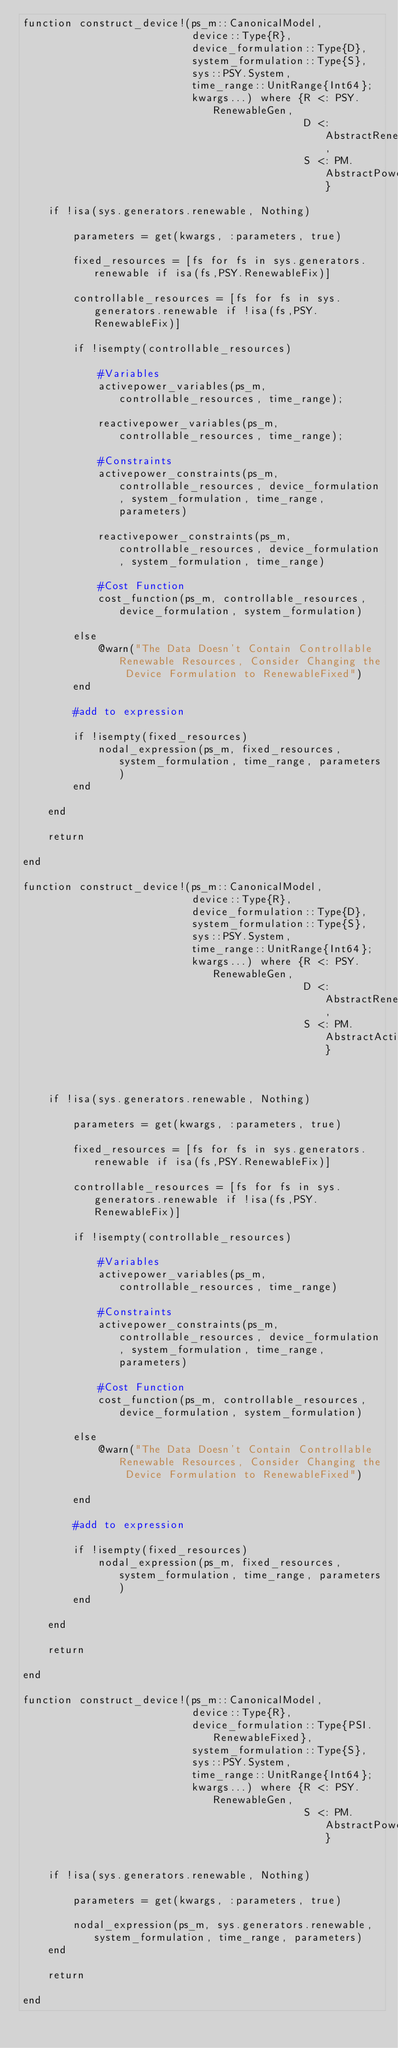<code> <loc_0><loc_0><loc_500><loc_500><_Julia_>function construct_device!(ps_m::CanonicalModel,
                           device::Type{R},
                           device_formulation::Type{D},
                           system_formulation::Type{S},
                           sys::PSY.System,
                           time_range::UnitRange{Int64};
                           kwargs...) where {R <: PSY.RenewableGen,
                                             D <: AbstractRenewableDispatchForm,
                                             S <: PM.AbstractPowerFormulation}

    if !isa(sys.generators.renewable, Nothing)

        parameters = get(kwargs, :parameters, true)

        fixed_resources = [fs for fs in sys.generators.renewable if isa(fs,PSY.RenewableFix)]

        controllable_resources = [fs for fs in sys.generators.renewable if !isa(fs,PSY.RenewableFix)]

        if !isempty(controllable_resources)

            #Variables
            activepower_variables(ps_m, controllable_resources, time_range);

            reactivepower_variables(ps_m, controllable_resources, time_range);

            #Constraints
            activepower_constraints(ps_m, controllable_resources, device_formulation, system_formulation, time_range, parameters)

            reactivepower_constraints(ps_m, controllable_resources, device_formulation, system_formulation, time_range)

            #Cost Function
            cost_function(ps_m, controllable_resources, device_formulation, system_formulation)

        else
            @warn("The Data Doesn't Contain Controllable Renewable Resources, Consider Changing the Device Formulation to RenewableFixed")
        end

        #add to expression

        if !isempty(fixed_resources)
            nodal_expression(ps_m, fixed_resources, system_formulation, time_range, parameters)
        end

    end

    return

end

function construct_device!(ps_m::CanonicalModel,
                           device::Type{R},
                           device_formulation::Type{D},
                           system_formulation::Type{S},
                           sys::PSY.System,
                           time_range::UnitRange{Int64};
                           kwargs...) where {R <: PSY.RenewableGen,
                                             D <: AbstractRenewableDispatchForm,
                                             S <: PM.AbstractActivePowerFormulation}



    if !isa(sys.generators.renewable, Nothing)

        parameters = get(kwargs, :parameters, true)

        fixed_resources = [fs for fs in sys.generators.renewable if isa(fs,PSY.RenewableFix)]

        controllable_resources = [fs for fs in sys.generators.renewable if !isa(fs,PSY.RenewableFix)]

        if !isempty(controllable_resources)

            #Variables
            activepower_variables(ps_m, controllable_resources, time_range)

            #Constraints
            activepower_constraints(ps_m, controllable_resources, device_formulation, system_formulation, time_range, parameters)

            #Cost Function
            cost_function(ps_m, controllable_resources, device_formulation, system_formulation)

        else
            @warn("The Data Doesn't Contain Controllable Renewable Resources, Consider Changing the Device Formulation to RenewableFixed")

        end

        #add to expression

        if !isempty(fixed_resources)
            nodal_expression(ps_m, fixed_resources, system_formulation, time_range, parameters)
        end

    end

    return

end

function construct_device!(ps_m::CanonicalModel,
                           device::Type{R},
                           device_formulation::Type{PSI.RenewableFixed},
                           system_formulation::Type{S},
                           sys::PSY.System,
                           time_range::UnitRange{Int64};
                           kwargs...) where {R <: PSY.RenewableGen,
                                             S <: PM.AbstractPowerFormulation}


    if !isa(sys.generators.renewable, Nothing)

        parameters = get(kwargs, :parameters, true)

        nodal_expression(ps_m, sys.generators.renewable, system_formulation, time_range, parameters)
    end

    return

end
</code> 